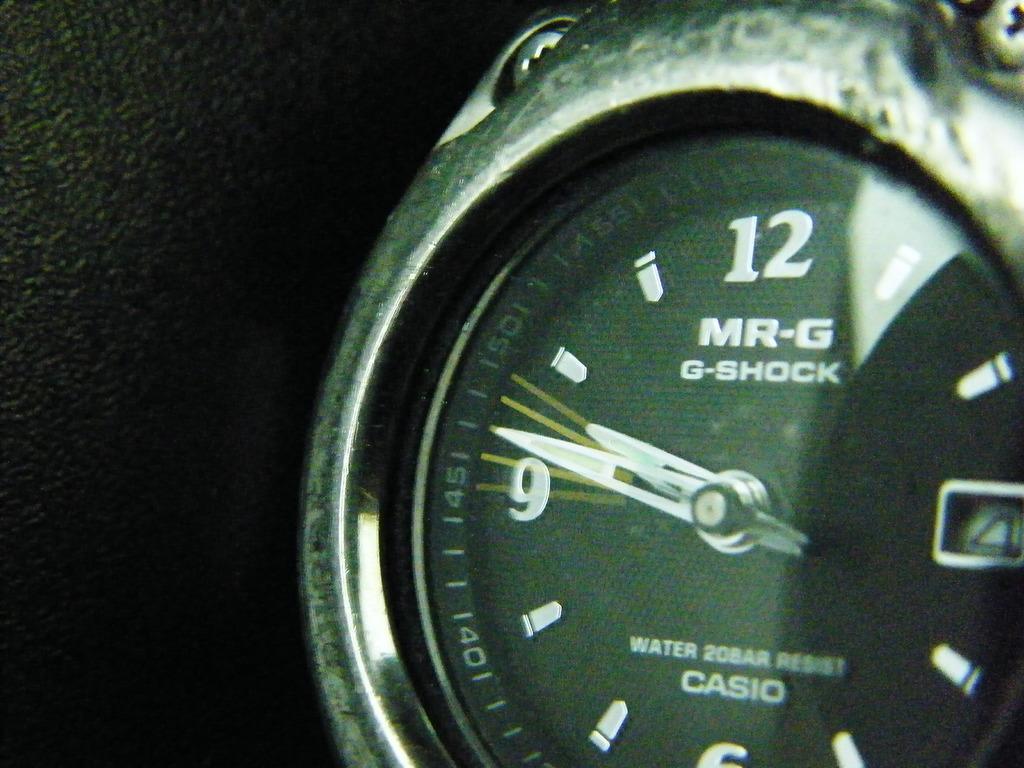Describe this image in one or two sentences. This picture contains a watch having short hand and a long hand. There are few numbers are on the frame which are in it. Beside watch there is leather. 